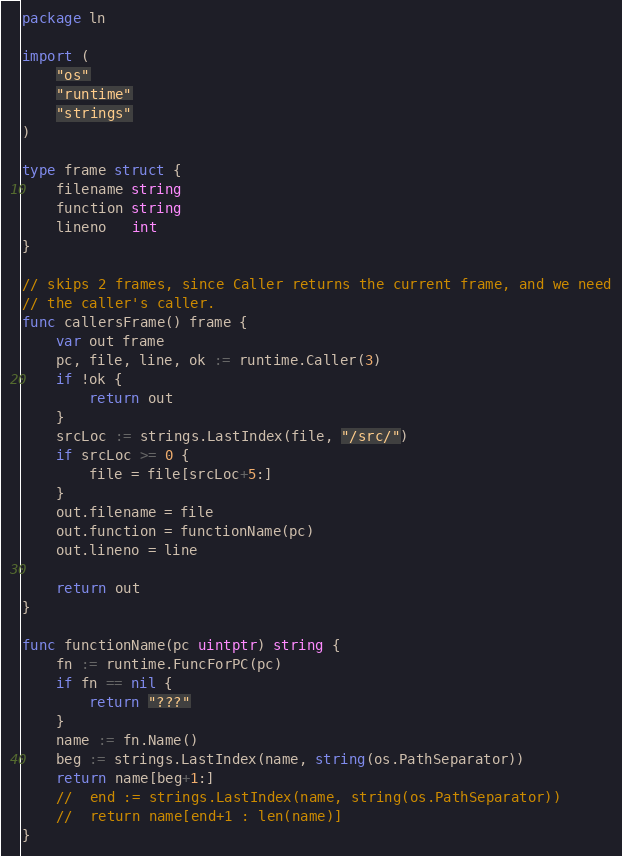Convert code to text. <code><loc_0><loc_0><loc_500><loc_500><_Go_>package ln

import (
	"os"
	"runtime"
	"strings"
)

type frame struct {
	filename string
	function string
	lineno   int
}

// skips 2 frames, since Caller returns the current frame, and we need
// the caller's caller.
func callersFrame() frame {
	var out frame
	pc, file, line, ok := runtime.Caller(3)
	if !ok {
		return out
	}
	srcLoc := strings.LastIndex(file, "/src/")
	if srcLoc >= 0 {
		file = file[srcLoc+5:]
	}
	out.filename = file
	out.function = functionName(pc)
	out.lineno = line

	return out
}

func functionName(pc uintptr) string {
	fn := runtime.FuncForPC(pc)
	if fn == nil {
		return "???"
	}
	name := fn.Name()
	beg := strings.LastIndex(name, string(os.PathSeparator))
	return name[beg+1:]
	//	end := strings.LastIndex(name, string(os.PathSeparator))
	//	return name[end+1 : len(name)]
}
</code> 